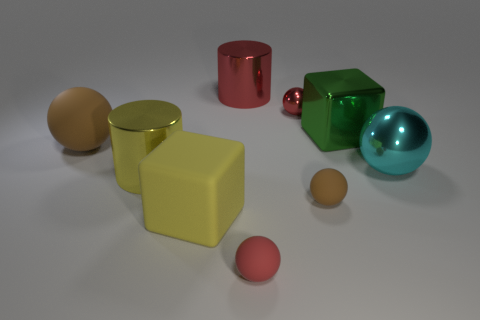Subtract all cyan cylinders. How many red balls are left? 2 Add 1 metallic balls. How many objects exist? 10 Subtract all cyan spheres. How many spheres are left? 4 Subtract all cyan spheres. How many spheres are left? 4 Subtract all cubes. How many objects are left? 7 Add 7 big gray objects. How many big gray objects exist? 7 Subtract 1 brown spheres. How many objects are left? 8 Subtract all red cylinders. Subtract all cyan cubes. How many cylinders are left? 1 Subtract all big yellow metal cylinders. Subtract all big yellow cylinders. How many objects are left? 7 Add 7 tiny red spheres. How many tiny red spheres are left? 9 